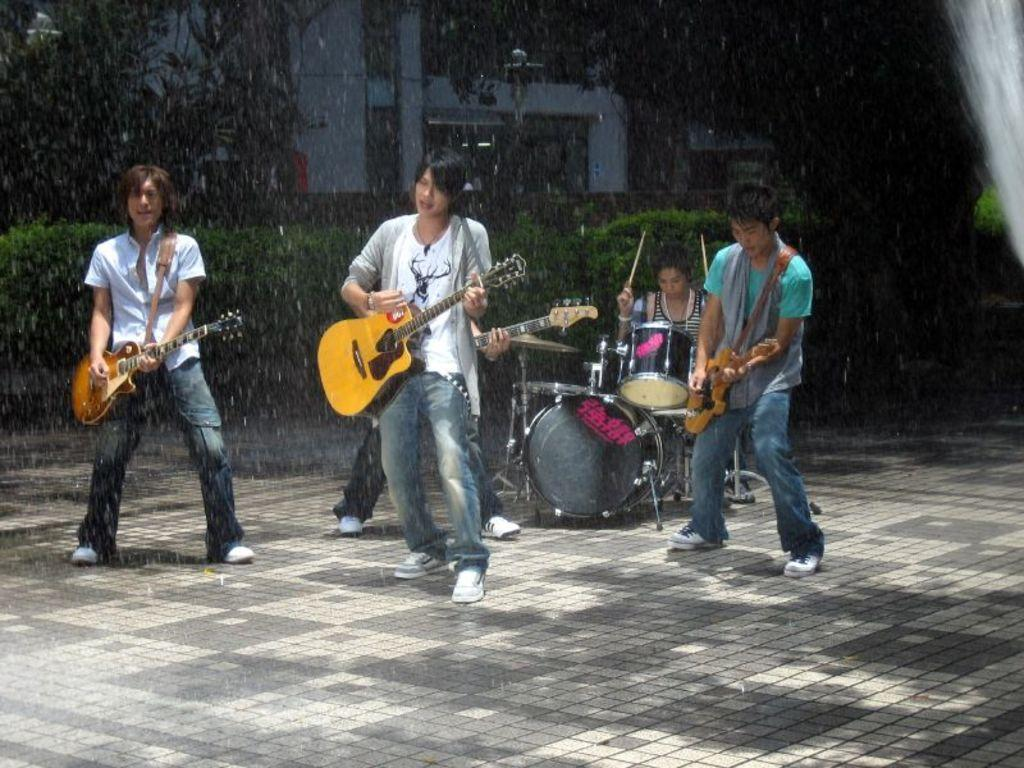How many men are in the image? There are three men in the image. What are the men doing in the image? Each man is holding a guitar and playing it. Is there anyone else playing an instrument in the image? Yes, there is a person playing drums in the image. What can be seen in the background of the image? Trees and a house are visible in the background. What type of cracker is being used as a drumstick in the image? There is no cracker being used as a drumstick in the image; the drummer is using traditional drumsticks. What direction is the zephyr blowing in the image? There is no mention of a zephyr or wind in the image; it is focused on the musicians and their instruments. 